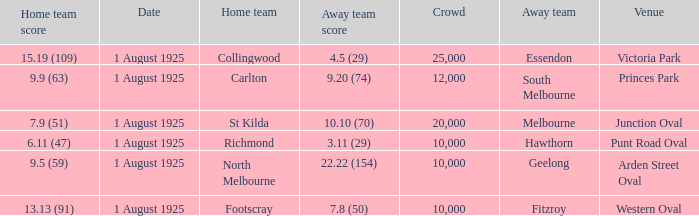5 (29), what was the audience size? 1.0. 